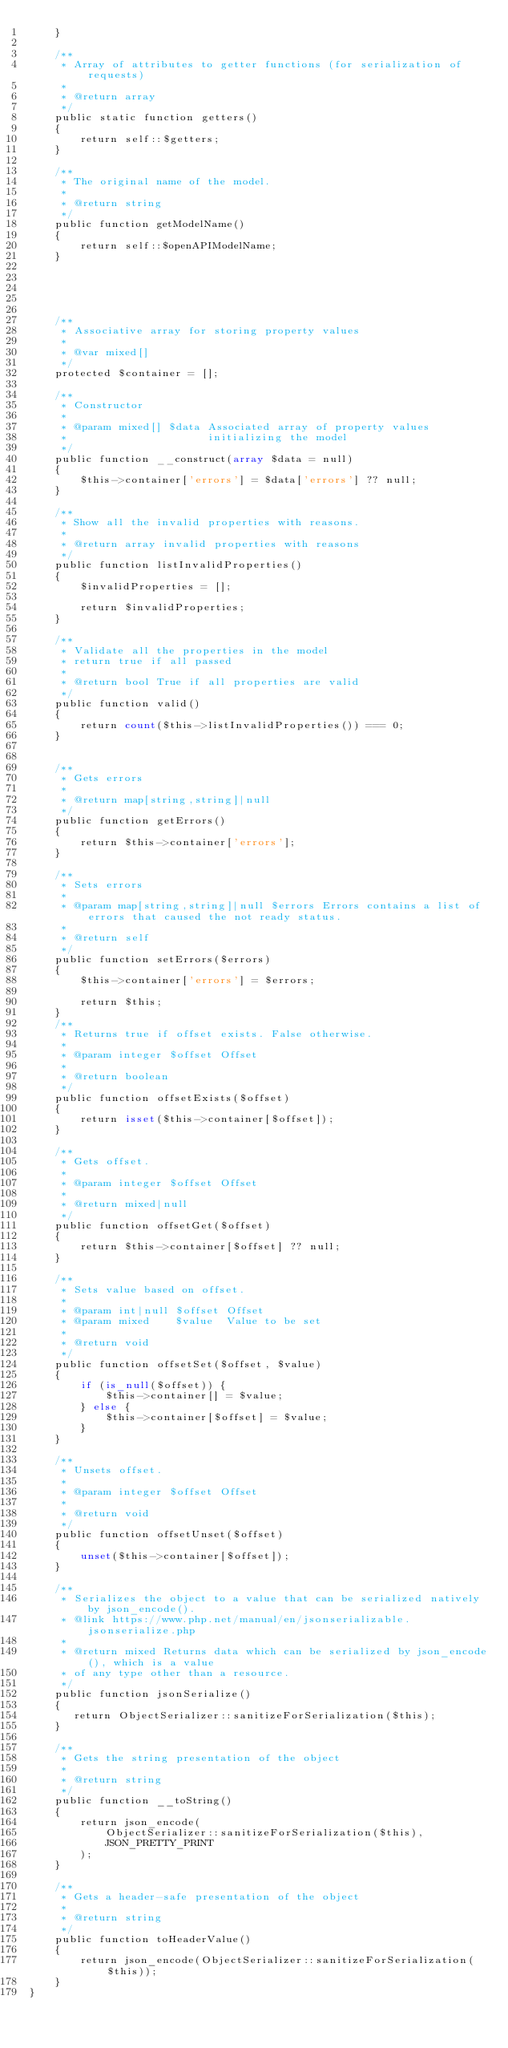<code> <loc_0><loc_0><loc_500><loc_500><_PHP_>    }

    /**
     * Array of attributes to getter functions (for serialization of requests)
     *
     * @return array
     */
    public static function getters()
    {
        return self::$getters;
    }

    /**
     * The original name of the model.
     *
     * @return string
     */
    public function getModelName()
    {
        return self::$openAPIModelName;
    }

    

    

    /**
     * Associative array for storing property values
     *
     * @var mixed[]
     */
    protected $container = [];

    /**
     * Constructor
     *
     * @param mixed[] $data Associated array of property values
     *                      initializing the model
     */
    public function __construct(array $data = null)
    {
        $this->container['errors'] = $data['errors'] ?? null;
    }

    /**
     * Show all the invalid properties with reasons.
     *
     * @return array invalid properties with reasons
     */
    public function listInvalidProperties()
    {
        $invalidProperties = [];

        return $invalidProperties;
    }

    /**
     * Validate all the properties in the model
     * return true if all passed
     *
     * @return bool True if all properties are valid
     */
    public function valid()
    {
        return count($this->listInvalidProperties()) === 0;
    }


    /**
     * Gets errors
     *
     * @return map[string,string]|null
     */
    public function getErrors()
    {
        return $this->container['errors'];
    }

    /**
     * Sets errors
     *
     * @param map[string,string]|null $errors Errors contains a list of errors that caused the not ready status.
     *
     * @return self
     */
    public function setErrors($errors)
    {
        $this->container['errors'] = $errors;

        return $this;
    }
    /**
     * Returns true if offset exists. False otherwise.
     *
     * @param integer $offset Offset
     *
     * @return boolean
     */
    public function offsetExists($offset)
    {
        return isset($this->container[$offset]);
    }

    /**
     * Gets offset.
     *
     * @param integer $offset Offset
     *
     * @return mixed|null
     */
    public function offsetGet($offset)
    {
        return $this->container[$offset] ?? null;
    }

    /**
     * Sets value based on offset.
     *
     * @param int|null $offset Offset
     * @param mixed    $value  Value to be set
     *
     * @return void
     */
    public function offsetSet($offset, $value)
    {
        if (is_null($offset)) {
            $this->container[] = $value;
        } else {
            $this->container[$offset] = $value;
        }
    }

    /**
     * Unsets offset.
     *
     * @param integer $offset Offset
     *
     * @return void
     */
    public function offsetUnset($offset)
    {
        unset($this->container[$offset]);
    }

    /**
     * Serializes the object to a value that can be serialized natively by json_encode().
     * @link https://www.php.net/manual/en/jsonserializable.jsonserialize.php
     *
     * @return mixed Returns data which can be serialized by json_encode(), which is a value
     * of any type other than a resource.
     */
    public function jsonSerialize()
    {
       return ObjectSerializer::sanitizeForSerialization($this);
    }

    /**
     * Gets the string presentation of the object
     *
     * @return string
     */
    public function __toString()
    {
        return json_encode(
            ObjectSerializer::sanitizeForSerialization($this),
            JSON_PRETTY_PRINT
        );
    }

    /**
     * Gets a header-safe presentation of the object
     *
     * @return string
     */
    public function toHeaderValue()
    {
        return json_encode(ObjectSerializer::sanitizeForSerialization($this));
    }
}


</code> 